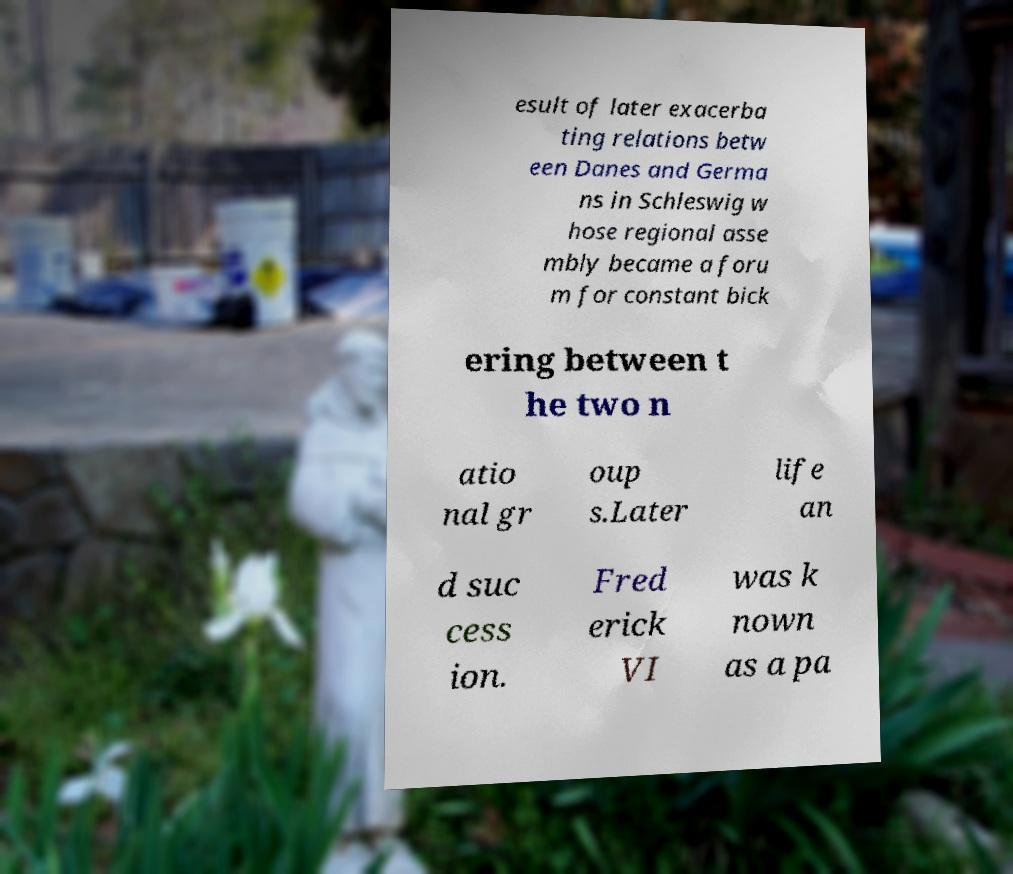For documentation purposes, I need the text within this image transcribed. Could you provide that? esult of later exacerba ting relations betw een Danes and Germa ns in Schleswig w hose regional asse mbly became a foru m for constant bick ering between t he two n atio nal gr oup s.Later life an d suc cess ion. Fred erick VI was k nown as a pa 